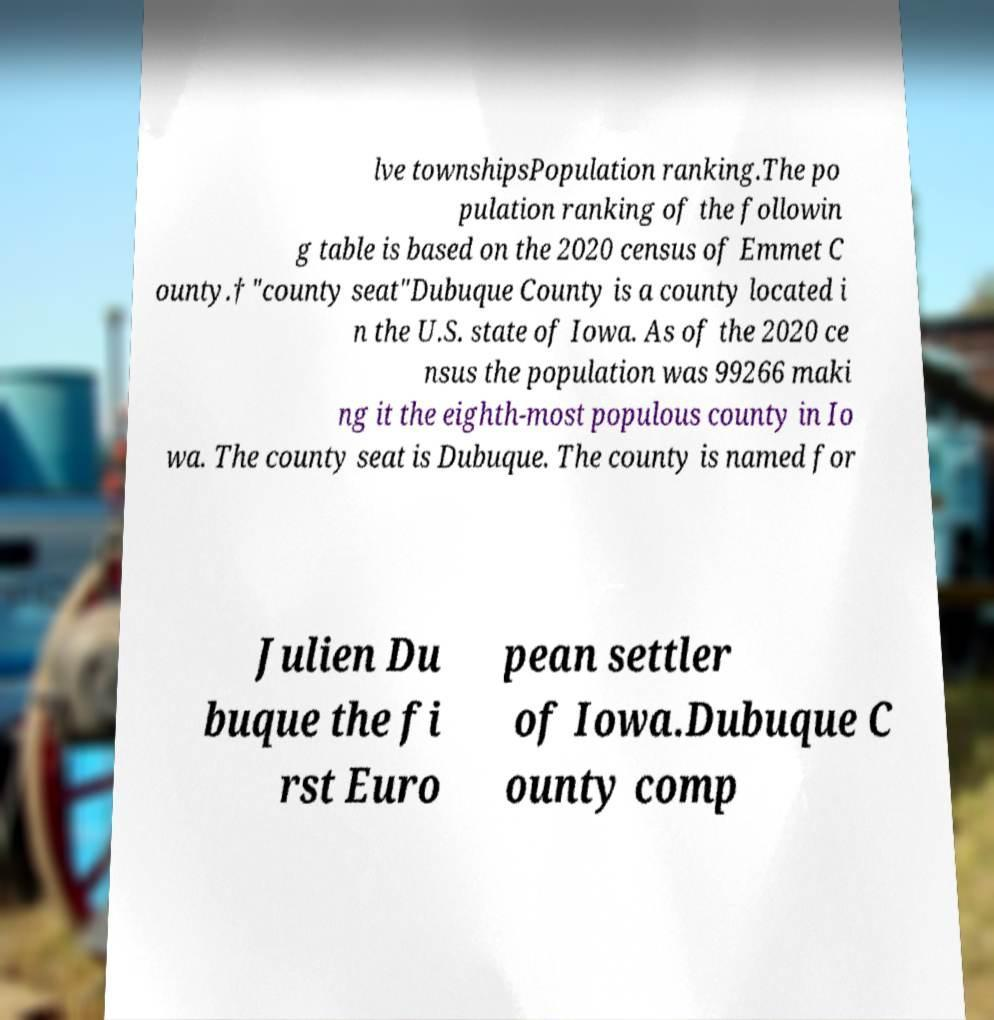I need the written content from this picture converted into text. Can you do that? lve townshipsPopulation ranking.The po pulation ranking of the followin g table is based on the 2020 census of Emmet C ounty.† "county seat"Dubuque County is a county located i n the U.S. state of Iowa. As of the 2020 ce nsus the population was 99266 maki ng it the eighth-most populous county in Io wa. The county seat is Dubuque. The county is named for Julien Du buque the fi rst Euro pean settler of Iowa.Dubuque C ounty comp 